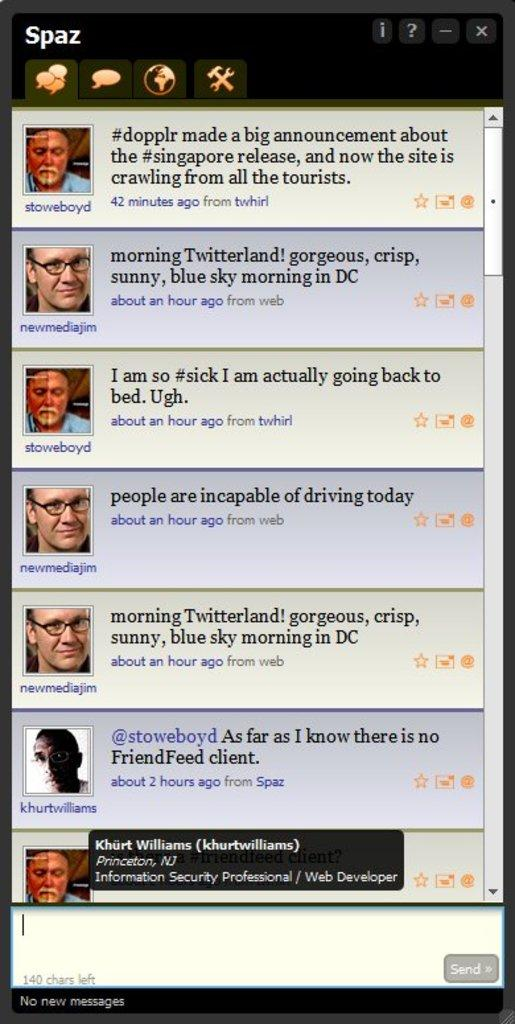What is the main object in the image that resembles a digital screen? There is an object in the image that resembles a digital screen. What can be seen on the digital screen? The digital screen displays images of humans. Is there any text present on the digital screen? Yes, there is text present on the digital screen. What type of comb is being used by the person in the image? There is no person or comb present in the image; it features a digital screen displaying images of humans. 